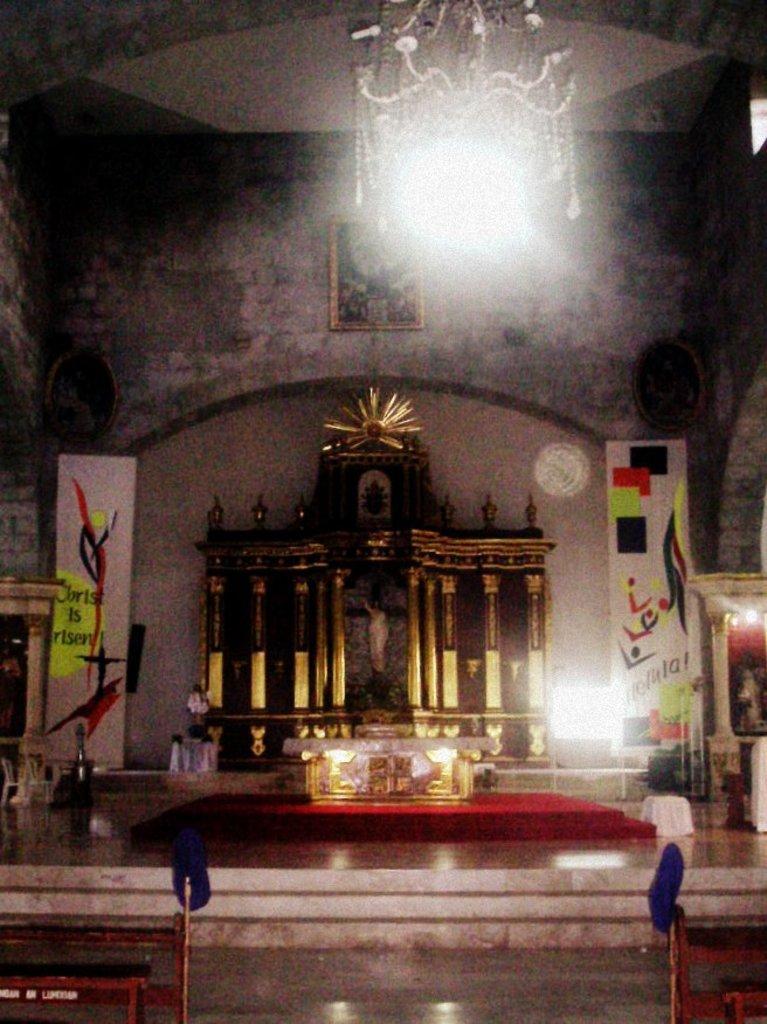Can you describe this image briefly? In this image I can see a stage, on the stage I can see a idol attached to the wall and there is a photo frame attached to the wall, at the top there is a chandelier and there are two hoarding boards and there are symbols and text on boards, there are some benches visible at the bottom. 